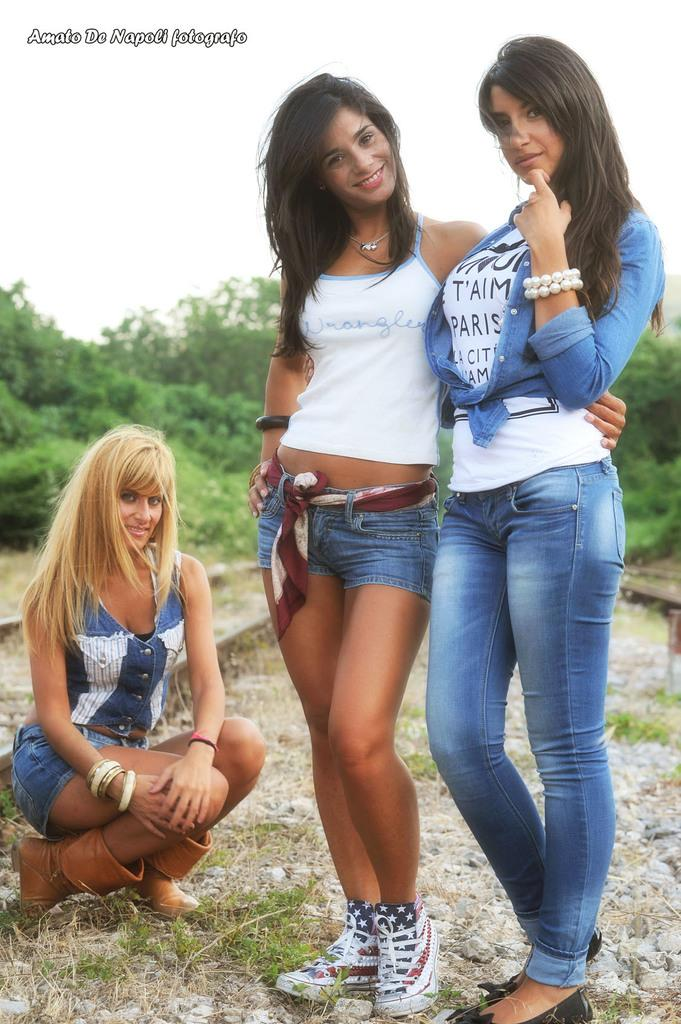How many women are in the image? There are three women in the image. What is the facial expression of the women? The women are smiling. Can you describe the position of one of the women? One woman is in a squat position. Where are the women standing? The women are standing on the ground. What can be seen in the background of the image? There are trees and the sky visible in the background of the image. What type of knowledge is the woman in the squat position sharing with the others in the image? There is no indication in the image that the women are sharing knowledge or discussing any particular topic. 